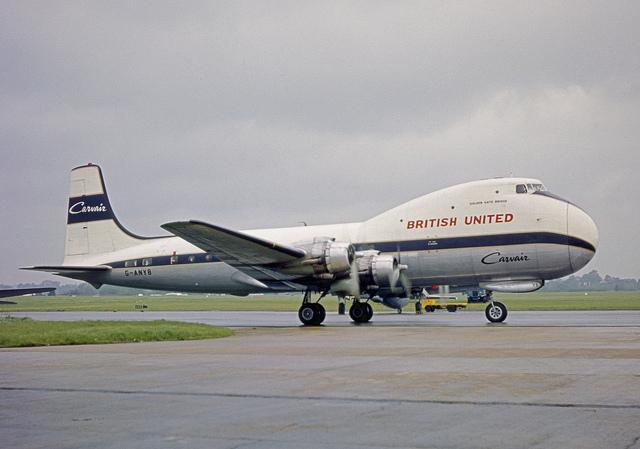Is the plane landing or taking off?
Answer briefly. Taking off. What type of plane is this?
Be succinct. Passenger. Is this a cargo plane?
Be succinct. No. What country is the plane from?
Quick response, please. Britain. What color is the plane?
Keep it brief. White. What does the plane have written on the front?
Short answer required. British united. What company owns this jet?
Short answer required. British united. What airline does the airplane belong to?
Concise answer only. British united. What is the paint color of the world British United?
Give a very brief answer. Red. 